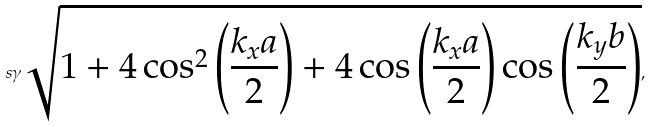Convert formula to latex. <formula><loc_0><loc_0><loc_500><loc_500>s \gamma \sqrt { 1 + 4 \cos ^ { 2 } \left ( \frac { k _ { x } a } { 2 } \right ) + 4 \cos \left ( \frac { k _ { x } a } { 2 } \right ) \cos \left ( \frac { k _ { y } b } { 2 } \right ) } ,</formula> 